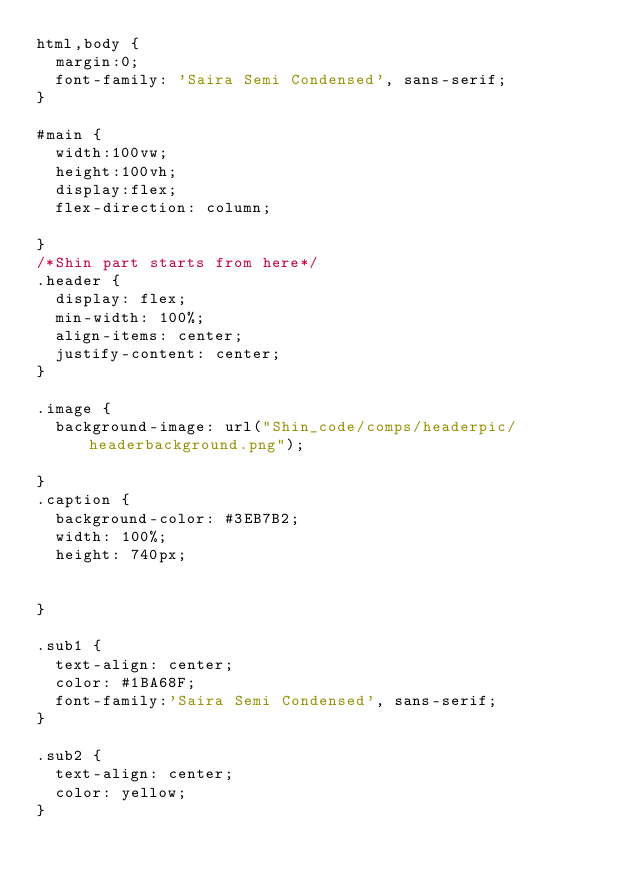<code> <loc_0><loc_0><loc_500><loc_500><_CSS_>html,body {
  margin:0;
  font-family: 'Saira Semi Condensed', sans-serif;
}

#main {
  width:100vw;
  height:100vh;
  display:flex;
  flex-direction: column;
 
}
/*Shin part starts from here*/
.header {
  display: flex;
  min-width: 100%;
  align-items: center;
  justify-content: center;
}

.image {
  background-image: url("Shin_code/comps/headerpic/headerbackground.png");

}
.caption {
  background-color: #3EB7B2;
  width: 100%;
  height: 740px;
  

}

.sub1 {
  text-align: center;
  color: #1BA68F;
  font-family:'Saira Semi Condensed', sans-serif;
}

.sub2 {
  text-align: center;
  color: yellow;
}
</code> 